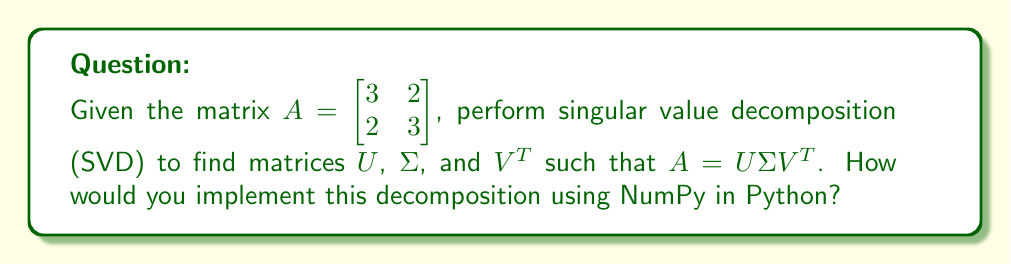Could you help me with this problem? To perform SVD on matrix $A$ and implement it using NumPy, follow these steps:

1. Import NumPy:
```python
import numpy as np
```

2. Define the matrix $A$:
```python
A = np.array([[3, 2], [2, 3]])
```

3. Use NumPy's `linalg.svd()` function to compute SVD:
```python
U, s, VT = np.linalg.svd(A)
```

4. The `svd()` function returns:
   - $U$: Left singular vectors
   - $s$: Singular values (as a 1D array)
   - $VT$: Transpose of right singular vectors

5. To construct $\Sigma$, create a diagonal matrix from $s$:
```python
Sigma = np.diag(s)
```

6. Verify the decomposition:
```python
reconstructed_A = np.dot(U, np.dot(Sigma, VT))
```

7. The resulting matrices are:

   $U = \begin{bmatrix} -0.7071 & -0.7071 \\ -0.7071 & 0.7071 \end{bmatrix}$

   $\Sigma = \begin{bmatrix} 5 & 0 \\ 0 & 1 \end{bmatrix}$

   $V^T = \begin{bmatrix} -0.7071 & -0.7071 \\ 0.7071 & -0.7071 \end{bmatrix}$

8. You can verify that $A \approx U\Sigma V^T$ (within numerical precision).

This implementation allows you to perform SVD on the given matrix using NumPy, which is efficient and commonly used in scientific computing and data analysis tasks in Python.
Answer: ```python
import numpy as np
A = np.array([[3, 2], [2, 3]])
U, s, VT = np.linalg.svd(A)
Sigma = np.diag(s)
``` 